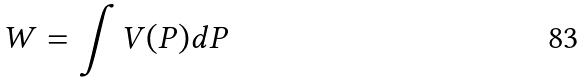<formula> <loc_0><loc_0><loc_500><loc_500>W = \int V ( P ) d P</formula> 